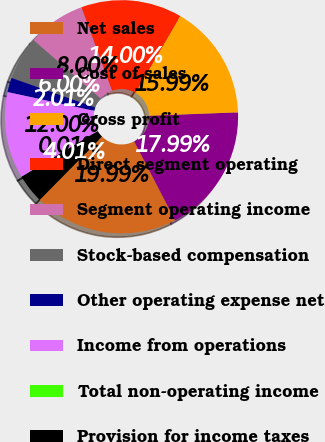<chart> <loc_0><loc_0><loc_500><loc_500><pie_chart><fcel>Net sales<fcel>Cost of sales<fcel>Gross profit<fcel>Direct segment operating<fcel>Segment operating income<fcel>Stock-based compensation<fcel>Other operating expense net<fcel>Income from operations<fcel>Total non-operating income<fcel>Provision for income taxes<nl><fcel>19.99%<fcel>17.99%<fcel>15.99%<fcel>14.0%<fcel>8.0%<fcel>6.0%<fcel>2.01%<fcel>12.0%<fcel>0.01%<fcel>4.01%<nl></chart> 